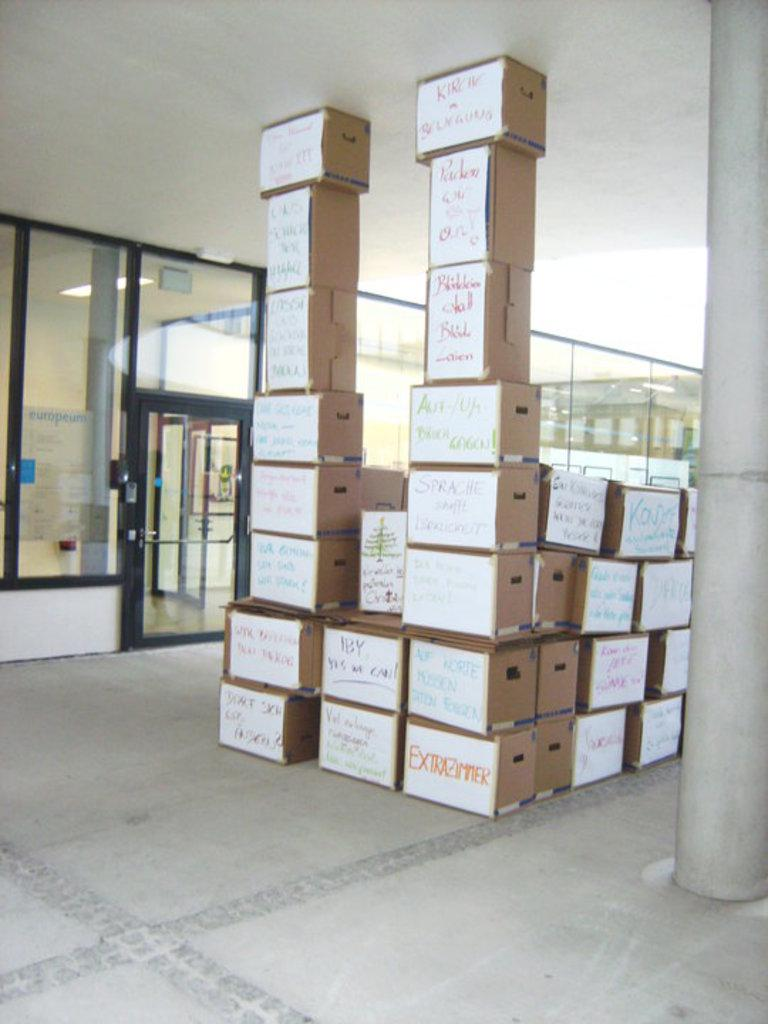<image>
Create a compact narrative representing the image presented. A box labeled Extrazimmer is at the bottom of a huge stack of cardboard boxes. 